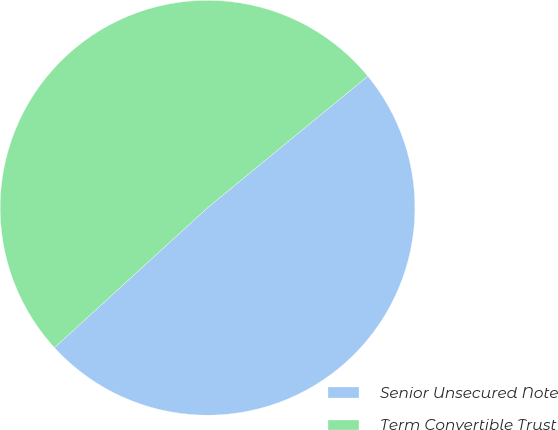Convert chart to OTSL. <chart><loc_0><loc_0><loc_500><loc_500><pie_chart><fcel>Senior Unsecured Note<fcel>Term Convertible Trust<nl><fcel>49.16%<fcel>50.84%<nl></chart> 